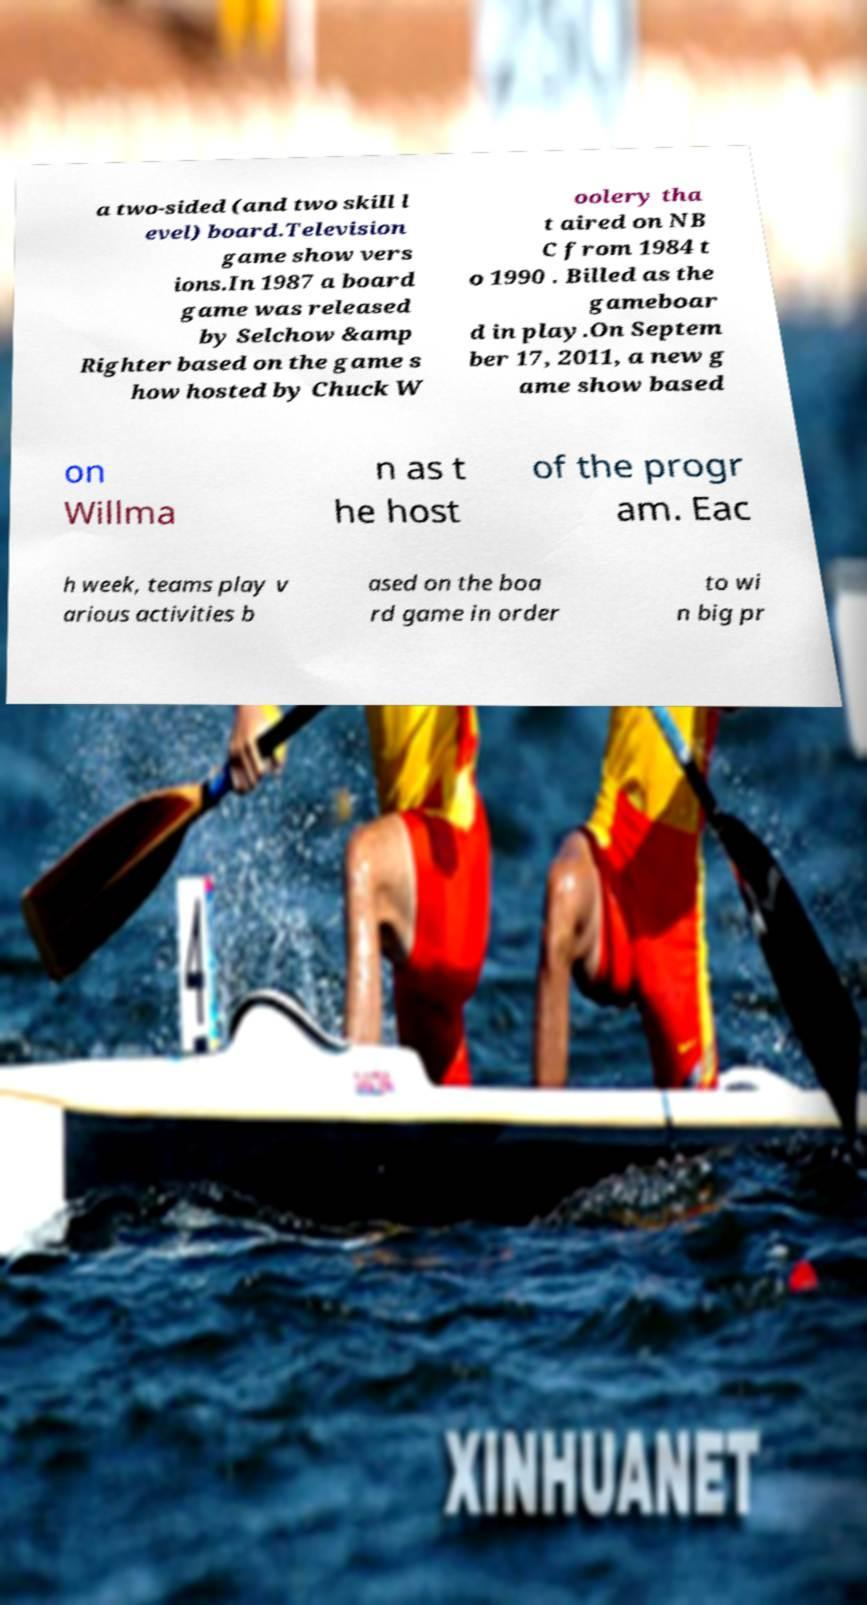Could you extract and type out the text from this image? a two-sided (and two skill l evel) board.Television game show vers ions.In 1987 a board game was released by Selchow &amp Righter based on the game s how hosted by Chuck W oolery tha t aired on NB C from 1984 t o 1990 . Billed as the gameboar d in play.On Septem ber 17, 2011, a new g ame show based on Willma n as t he host of the progr am. Eac h week, teams play v arious activities b ased on the boa rd game in order to wi n big pr 